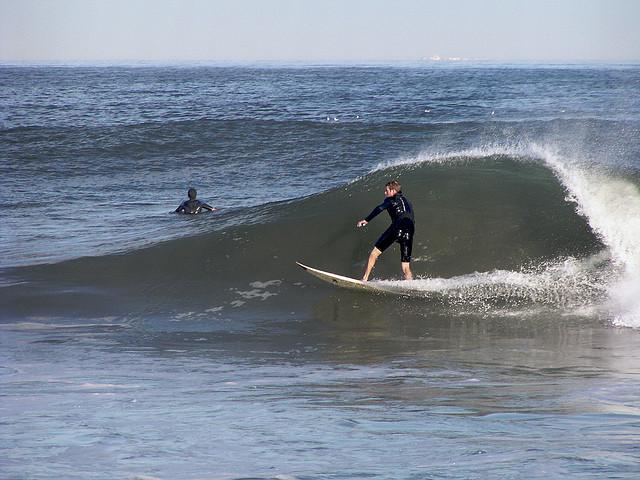How many people are laying on their board?
Write a very short answer. 1. Is one of the people swimming?
Give a very brief answer. Yes. What sport are they participating in?
Answer briefly. Surfing. 